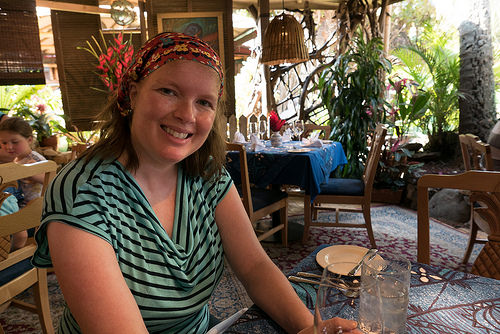<image>
Can you confirm if the flowers is on the woman? No. The flowers is not positioned on the woman. They may be near each other, but the flowers is not supported by or resting on top of the woman. Is there a palm to the right of the lamp shade? Yes. From this viewpoint, the palm is positioned to the right side relative to the lamp shade. 